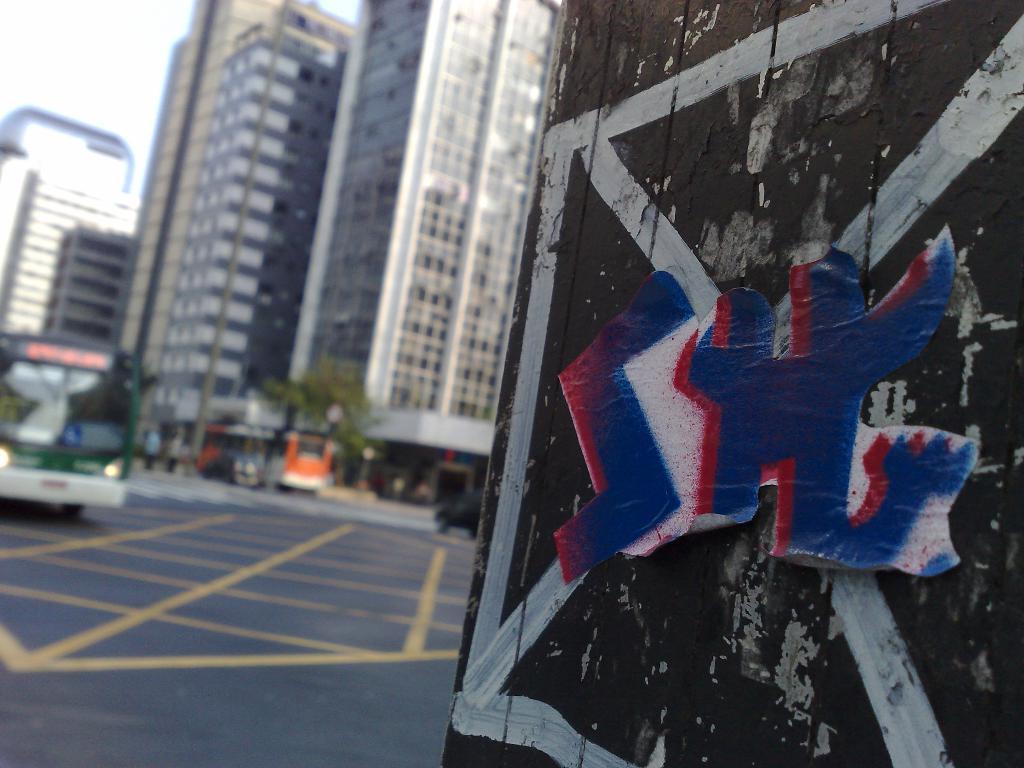Could you give a brief overview of what you see in this image? In this image we can see a wall with painting and a sticker and in the background there are few buildings, trees, persons and vehicles on the road. 